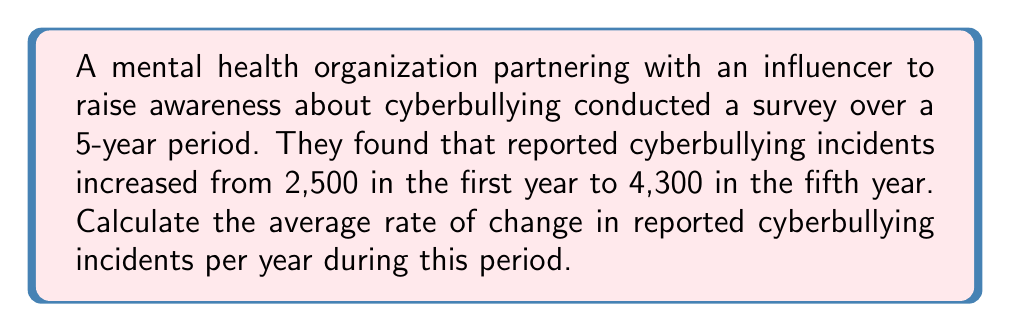What is the answer to this math problem? To calculate the average rate of change, we need to follow these steps:

1. Identify the initial and final values:
   Initial value (year 1): 2,500 incidents
   Final value (year 5): 4,300 incidents

2. Calculate the total change in incidents:
   $\text{Total change} = \text{Final value} - \text{Initial value}$
   $\text{Total change} = 4,300 - 2,500 = 1,800$ incidents

3. Determine the time interval:
   Time interval = 5 years

4. Calculate the average rate of change using the formula:
   $$\text{Average rate of change} = \frac{\text{Change in y}}{\text{Change in x}} = \frac{\text{Total change}}{\text{Time interval}}$$

5. Substitute the values:
   $$\text{Average rate of change} = \frac{1,800 \text{ incidents}}{5 \text{ years}} = 360 \text{ incidents per year}$$

Therefore, the average rate of change in reported cyberbullying incidents is 360 incidents per year over the 5-year period.
Answer: 360 incidents/year 